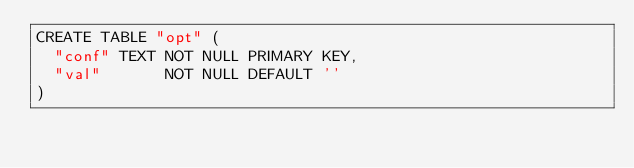<code> <loc_0><loc_0><loc_500><loc_500><_SQL_>CREATE TABLE "opt" (
  "conf" TEXT NOT NULL PRIMARY KEY,
  "val"       NOT NULL DEFAULT ''
)
</code> 